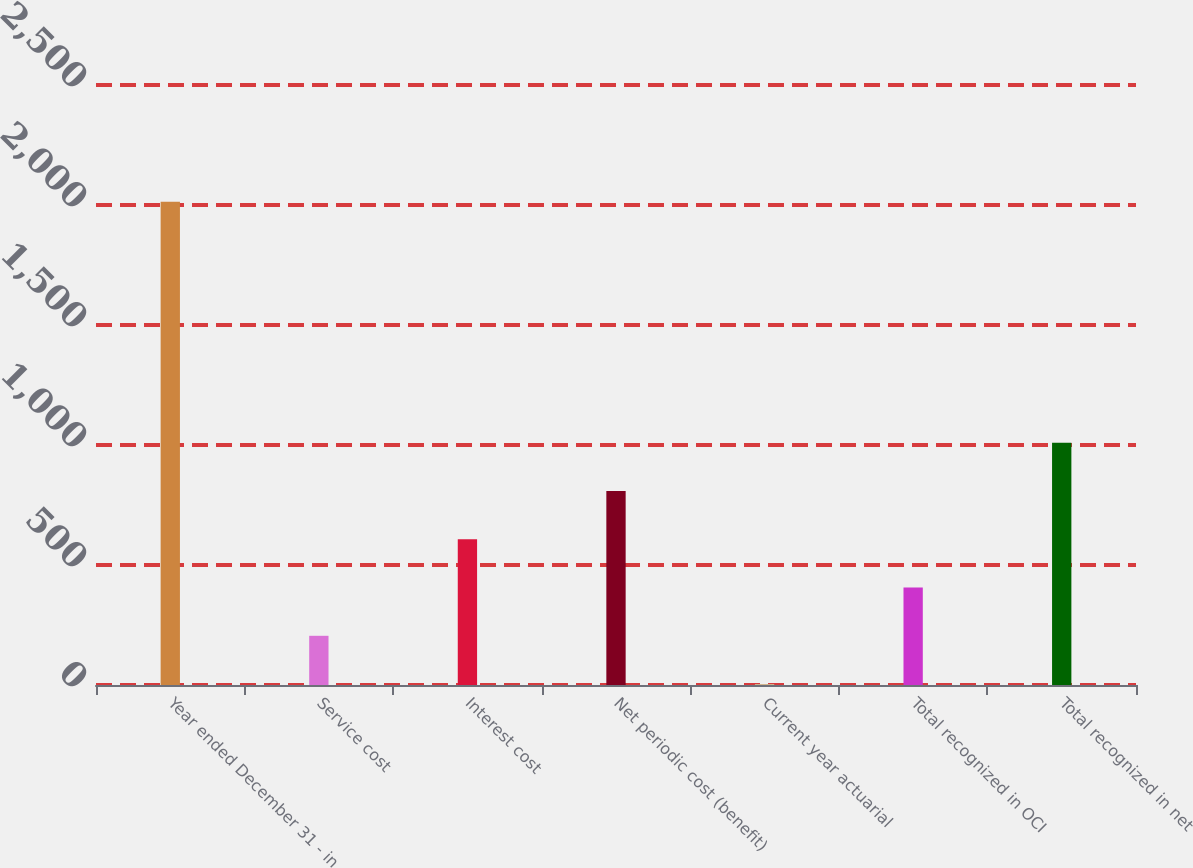Convert chart. <chart><loc_0><loc_0><loc_500><loc_500><bar_chart><fcel>Year ended December 31 - in<fcel>Service cost<fcel>Interest cost<fcel>Net periodic cost (benefit)<fcel>Current year actuarial<fcel>Total recognized in OCI<fcel>Total recognized in net<nl><fcel>2014<fcel>205<fcel>607<fcel>808<fcel>4<fcel>406<fcel>1009<nl></chart> 